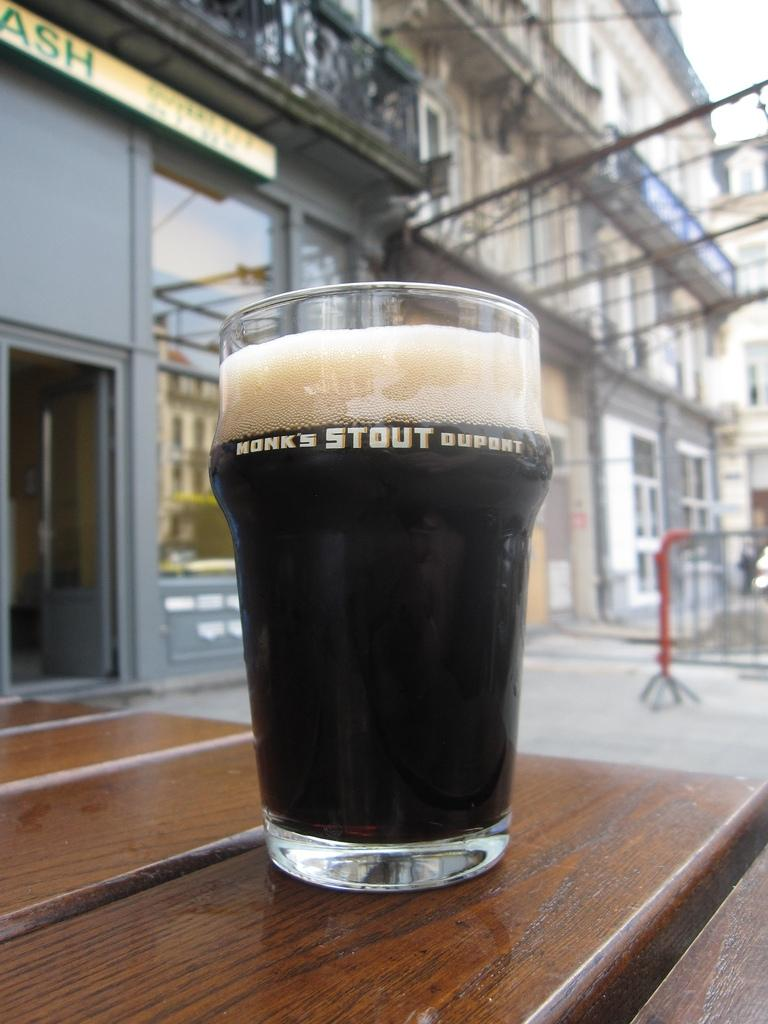Provide a one-sentence caption for the provided image. A fresh pour of Monk's Stout Dupont on a wooden table outside. 